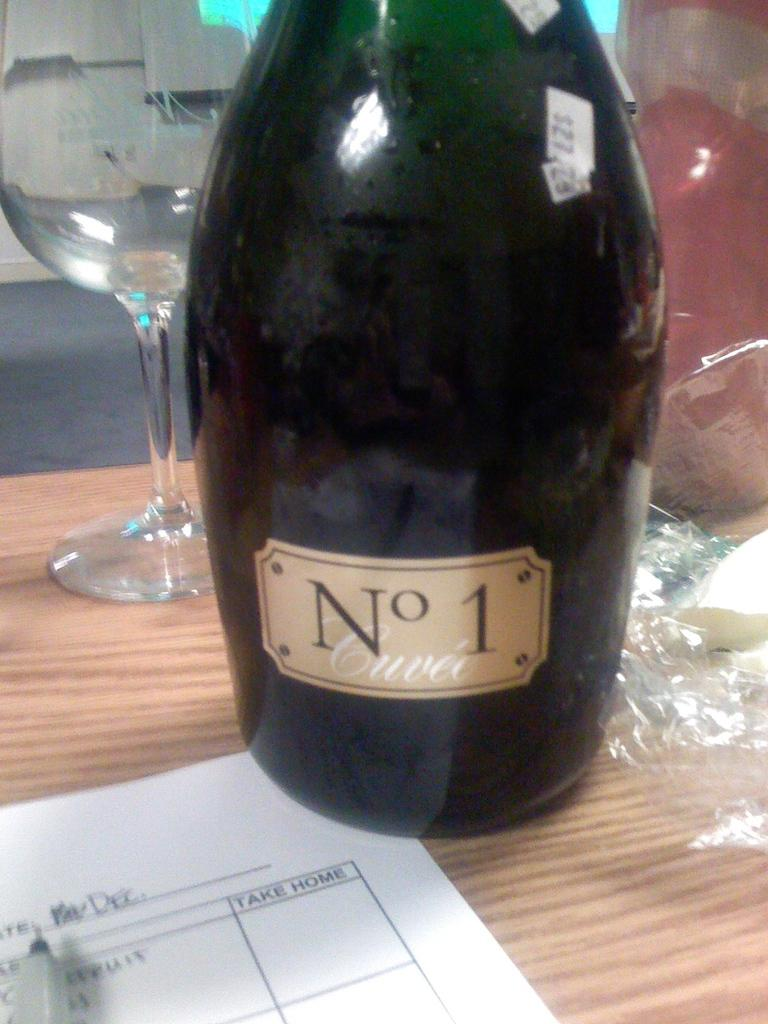<image>
Give a short and clear explanation of the subsequent image. A bottle of No 1 Cuvee sits on a table in front of wine glass and next to a paper that has a column named Take Home. 